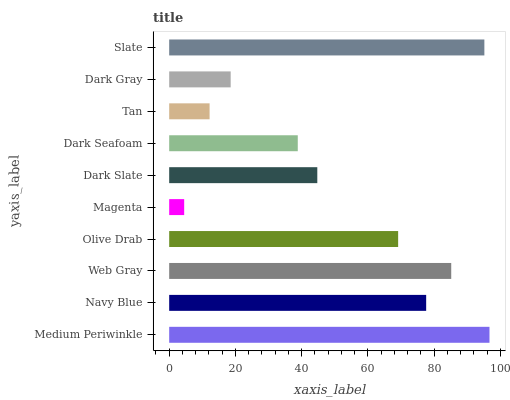Is Magenta the minimum?
Answer yes or no. Yes. Is Medium Periwinkle the maximum?
Answer yes or no. Yes. Is Navy Blue the minimum?
Answer yes or no. No. Is Navy Blue the maximum?
Answer yes or no. No. Is Medium Periwinkle greater than Navy Blue?
Answer yes or no. Yes. Is Navy Blue less than Medium Periwinkle?
Answer yes or no. Yes. Is Navy Blue greater than Medium Periwinkle?
Answer yes or no. No. Is Medium Periwinkle less than Navy Blue?
Answer yes or no. No. Is Olive Drab the high median?
Answer yes or no. Yes. Is Dark Slate the low median?
Answer yes or no. Yes. Is Navy Blue the high median?
Answer yes or no. No. Is Tan the low median?
Answer yes or no. No. 